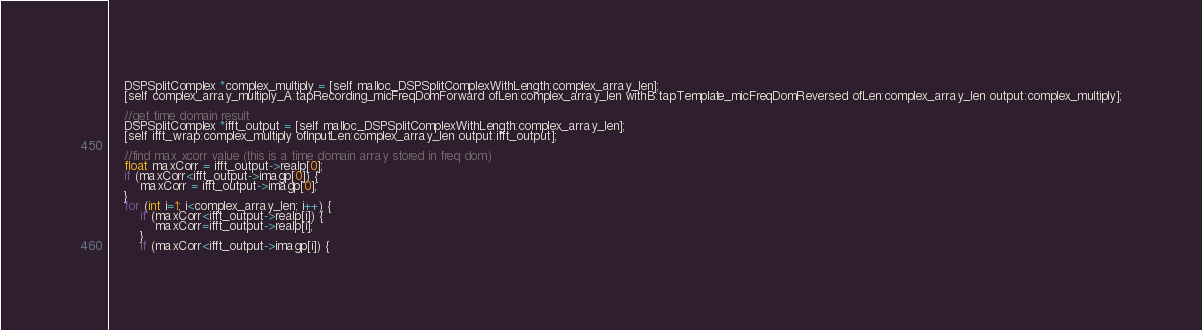<code> <loc_0><loc_0><loc_500><loc_500><_ObjectiveC_>    DSPSplitComplex *complex_multiply = [self malloc_DSPSplitComplexWithLength:complex_array_len];
    [self complex_array_multiply_A:tapRecording_micFreqDomForward ofLen:complex_array_len withB:tapTemplate_micFreqDomReversed ofLen:complex_array_len output:complex_multiply];
    
    //get time domain result
    DSPSplitComplex *ifft_output = [self malloc_DSPSplitComplexWithLength:complex_array_len];
    [self ifft_wrap:complex_multiply ofInputLen:complex_array_len output:ifft_output];
    
    //find max xcorr value (this is a time domain array stored in freq dom)
    float maxCorr = ifft_output->realp[0];
    if (maxCorr<ifft_output->imagp[0]) {
        maxCorr = ifft_output->imagp[0];
    }
    for (int i=1; i<complex_array_len; i++) {
        if (maxCorr<ifft_output->realp[i]) {
            maxCorr=ifft_output->realp[i];
        }
        if (maxCorr<ifft_output->imagp[i]) {</code> 